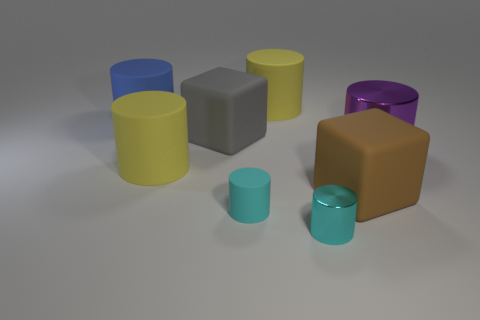Subtract all purple cylinders. How many cylinders are left? 5 Subtract all gray blocks. How many yellow cylinders are left? 2 Subtract all blue cylinders. How many cylinders are left? 5 Subtract all green cylinders. Subtract all brown balls. How many cylinders are left? 6 Add 1 big blue matte cylinders. How many objects exist? 9 Subtract all blocks. How many objects are left? 6 Subtract all big blue matte objects. Subtract all cyan matte cylinders. How many objects are left? 6 Add 1 purple metallic cylinders. How many purple metallic cylinders are left? 2 Add 8 small brown metallic spheres. How many small brown metallic spheres exist? 8 Subtract 0 gray cylinders. How many objects are left? 8 